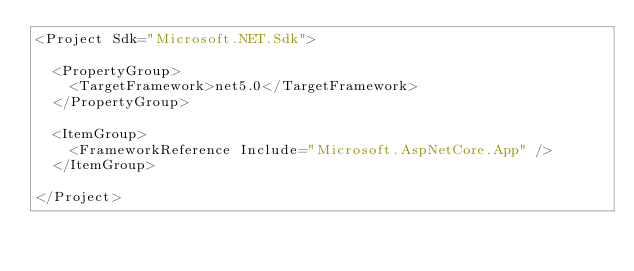<code> <loc_0><loc_0><loc_500><loc_500><_XML_><Project Sdk="Microsoft.NET.Sdk">

  <PropertyGroup>
    <TargetFramework>net5.0</TargetFramework>
  </PropertyGroup>

  <ItemGroup>
    <FrameworkReference Include="Microsoft.AspNetCore.App" />
  </ItemGroup>

</Project>
</code> 